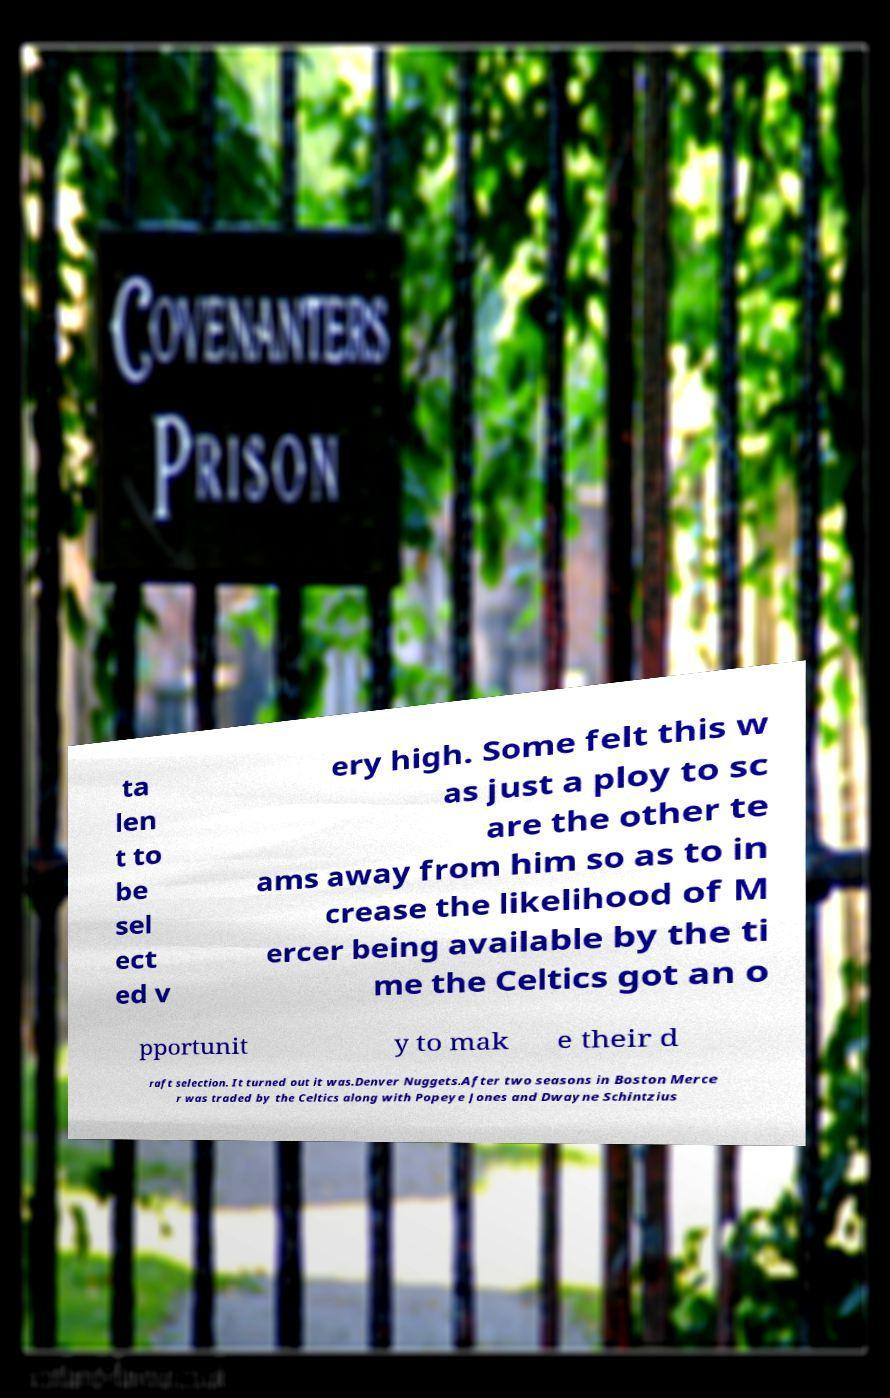Can you accurately transcribe the text from the provided image for me? ta len t to be sel ect ed v ery high. Some felt this w as just a ploy to sc are the other te ams away from him so as to in crease the likelihood of M ercer being available by the ti me the Celtics got an o pportunit y to mak e their d raft selection. It turned out it was.Denver Nuggets.After two seasons in Boston Merce r was traded by the Celtics along with Popeye Jones and Dwayne Schintzius 